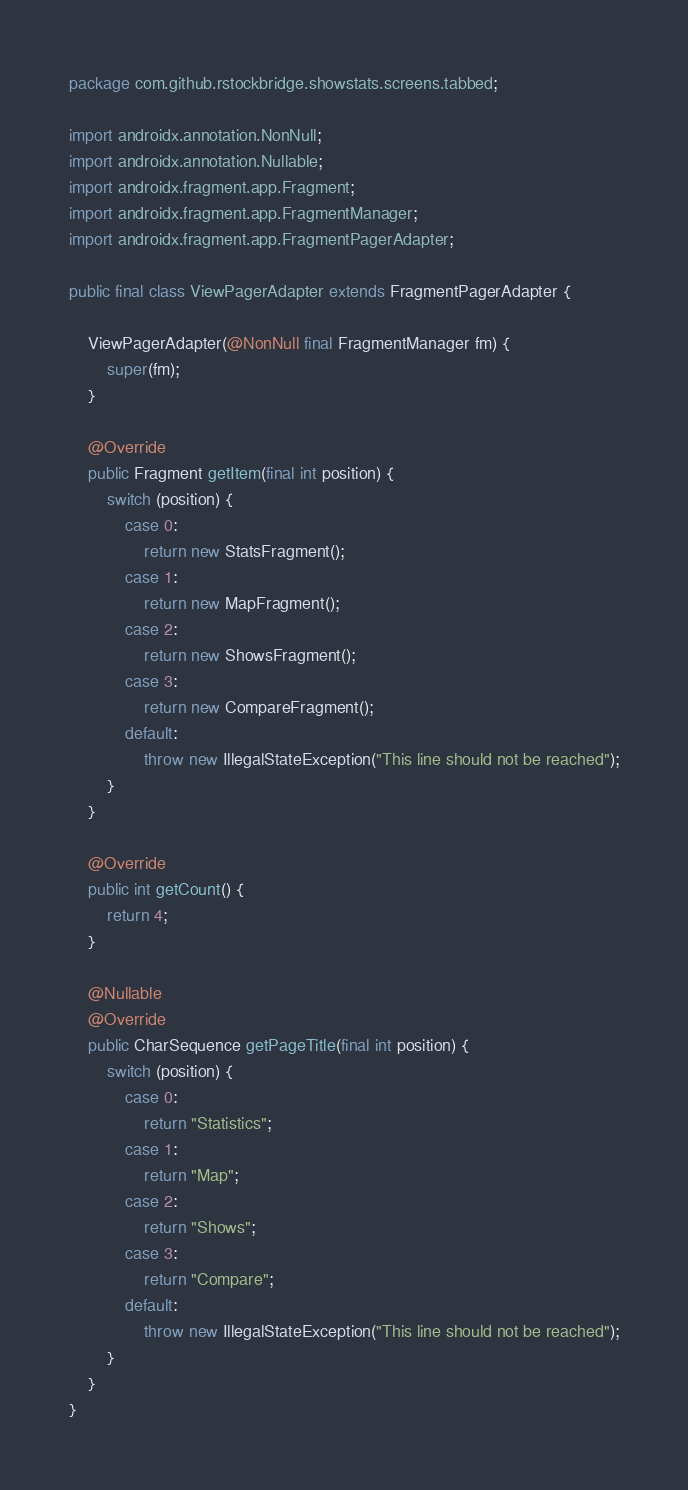Convert code to text. <code><loc_0><loc_0><loc_500><loc_500><_Java_>package com.github.rstockbridge.showstats.screens.tabbed;

import androidx.annotation.NonNull;
import androidx.annotation.Nullable;
import androidx.fragment.app.Fragment;
import androidx.fragment.app.FragmentManager;
import androidx.fragment.app.FragmentPagerAdapter;

public final class ViewPagerAdapter extends FragmentPagerAdapter {

    ViewPagerAdapter(@NonNull final FragmentManager fm) {
        super(fm);
    }

    @Override
    public Fragment getItem(final int position) {
        switch (position) {
            case 0:
                return new StatsFragment();
            case 1:
                return new MapFragment();
            case 2:
                return new ShowsFragment();
            case 3:
                return new CompareFragment();
            default:
                throw new IllegalStateException("This line should not be reached");
        }
    }

    @Override
    public int getCount() {
        return 4;
    }

    @Nullable
    @Override
    public CharSequence getPageTitle(final int position) {
        switch (position) {
            case 0:
                return "Statistics";
            case 1:
                return "Map";
            case 2:
                return "Shows";
            case 3:
                return "Compare";
            default:
                throw new IllegalStateException("This line should not be reached");
        }
    }
}
</code> 